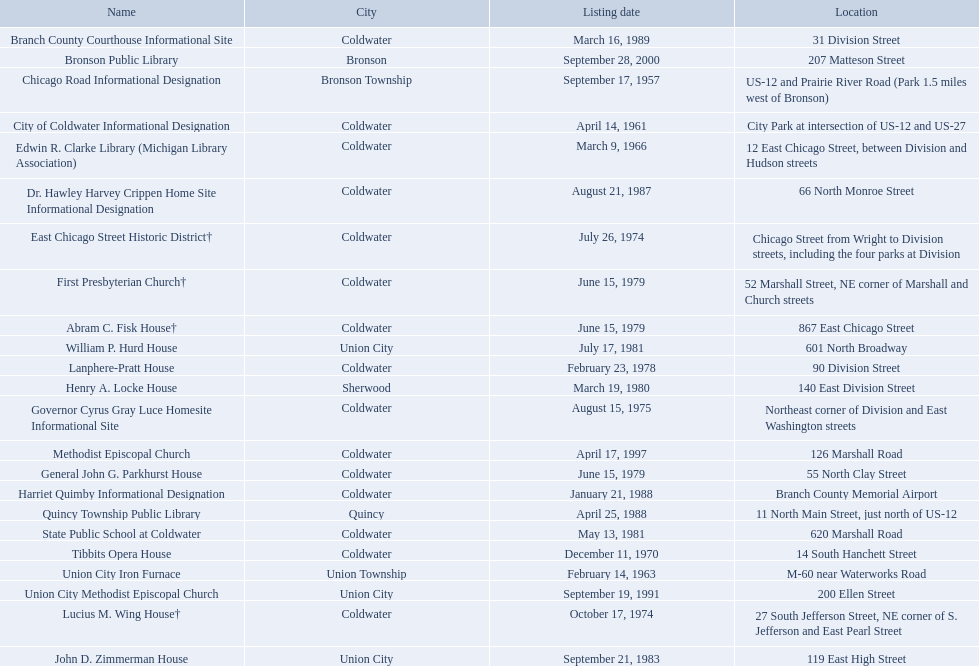What are all of the locations considered historical sites in branch county, michigan? Branch County Courthouse Informational Site, Bronson Public Library, Chicago Road Informational Designation, City of Coldwater Informational Designation, Edwin R. Clarke Library (Michigan Library Association), Dr. Hawley Harvey Crippen Home Site Informational Designation, East Chicago Street Historic District†, First Presbyterian Church†, Abram C. Fisk House†, William P. Hurd House, Lanphere-Pratt House, Henry A. Locke House, Governor Cyrus Gray Luce Homesite Informational Site, Methodist Episcopal Church, General John G. Parkhurst House, Harriet Quimby Informational Designation, Quincy Township Public Library, State Public School at Coldwater, Tibbits Opera House, Union City Iron Furnace, Union City Methodist Episcopal Church, Lucius M. Wing House†, John D. Zimmerman House. Of those sites, which one was the first to be listed as historical? Chicago Road Informational Designation. Write the full table. {'header': ['Name', 'City', 'Listing date', 'Location'], 'rows': [['Branch County Courthouse Informational Site', 'Coldwater', 'March 16, 1989', '31 Division Street'], ['Bronson Public Library', 'Bronson', 'September 28, 2000', '207 Matteson Street'], ['Chicago Road Informational Designation', 'Bronson Township', 'September 17, 1957', 'US-12 and Prairie River Road (Park 1.5 miles west of Bronson)'], ['City of Coldwater Informational Designation', 'Coldwater', 'April 14, 1961', 'City Park at intersection of US-12 and US-27'], ['Edwin R. Clarke Library (Michigan Library Association)', 'Coldwater', 'March 9, 1966', '12 East Chicago Street, between Division and Hudson streets'], ['Dr. Hawley Harvey Crippen Home Site Informational Designation', 'Coldwater', 'August 21, 1987', '66 North Monroe Street'], ['East Chicago Street Historic District†', 'Coldwater', 'July 26, 1974', 'Chicago Street from Wright to Division streets, including the four parks at Division'], ['First Presbyterian Church†', 'Coldwater', 'June 15, 1979', '52 Marshall Street, NE corner of Marshall and Church streets'], ['Abram C. Fisk House†', 'Coldwater', 'June 15, 1979', '867 East Chicago Street'], ['William P. Hurd House', 'Union City', 'July 17, 1981', '601 North Broadway'], ['Lanphere-Pratt House', 'Coldwater', 'February 23, 1978', '90 Division Street'], ['Henry A. Locke House', 'Sherwood', 'March 19, 1980', '140 East Division Street'], ['Governor Cyrus Gray Luce Homesite Informational Site', 'Coldwater', 'August 15, 1975', 'Northeast corner of Division and East Washington streets'], ['Methodist Episcopal Church', 'Coldwater', 'April 17, 1997', '126 Marshall Road'], ['General John G. Parkhurst House', 'Coldwater', 'June 15, 1979', '55 North Clay Street'], ['Harriet Quimby Informational Designation', 'Coldwater', 'January 21, 1988', 'Branch County Memorial Airport'], ['Quincy Township Public Library', 'Quincy', 'April 25, 1988', '11 North Main Street, just north of US-12'], ['State Public School at Coldwater', 'Coldwater', 'May 13, 1981', '620 Marshall Road'], ['Tibbits Opera House', 'Coldwater', 'December 11, 1970', '14 South Hanchett Street'], ['Union City Iron Furnace', 'Union Township', 'February 14, 1963', 'M-60 near Waterworks Road'], ['Union City Methodist Episcopal Church', 'Union City', 'September 19, 1991', '200 Ellen Street'], ['Lucius M. Wing House†', 'Coldwater', 'October 17, 1974', '27 South Jefferson Street, NE corner of S. Jefferson and East Pearl Street'], ['John D. Zimmerman House', 'Union City', 'September 21, 1983', '119 East High Street']]} 